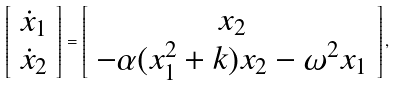Convert formula to latex. <formula><loc_0><loc_0><loc_500><loc_500>\left [ \begin{array} { c } \dot { x } _ { 1 } \\ \dot { x } _ { 2 } \\ \end{array} \right ] = \left [ \begin{array} { c } x _ { 2 } \\ - \alpha ( x _ { 1 } ^ { 2 } + k ) x _ { 2 } - \omega ^ { 2 } x _ { 1 } \\ \end{array} \right ] ,</formula> 